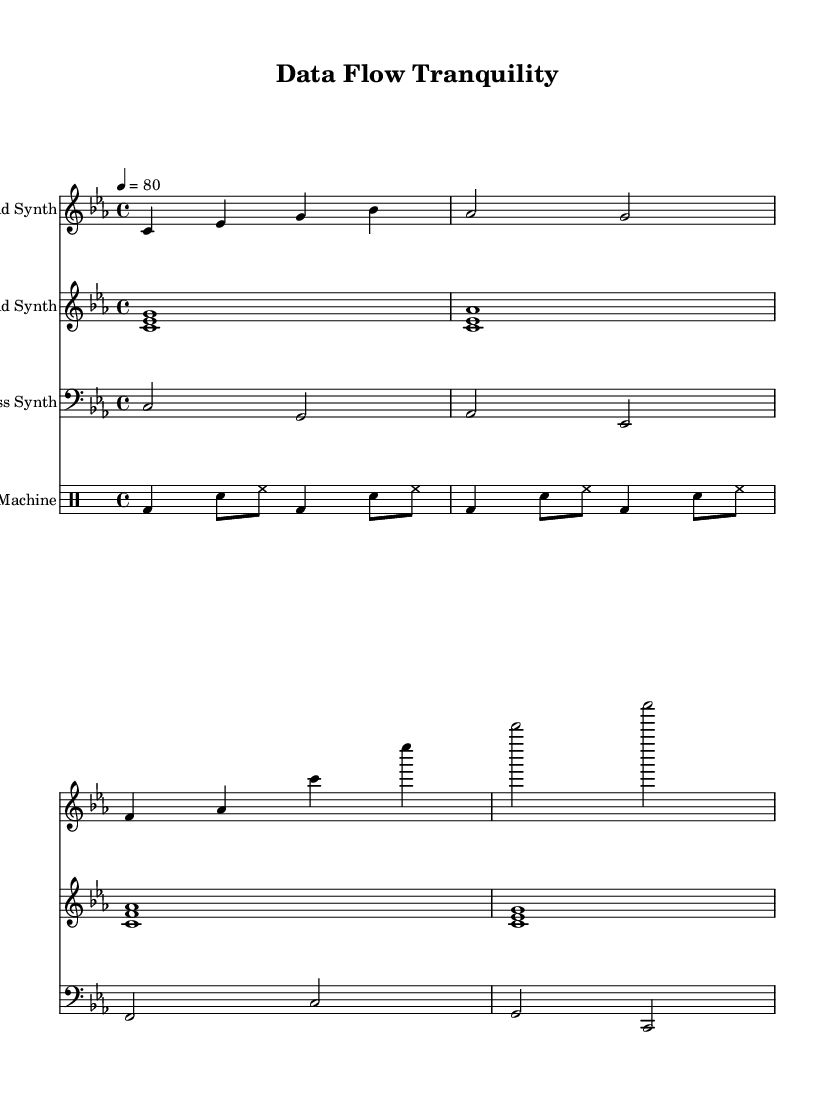What is the key signature of this music? The key signature is C minor, which is indicated by the presence of three flats (B♭, E♭, and A♭) in the key signature area.
Answer: C minor What is the time signature of this piece? The time signature is 4/4, which indicates four beats per measure and that each beat is a quarter note. This can be seen at the beginning of the score right after the key signature.
Answer: 4/4 What is the tempo marking for this piece? The tempo is marked as "4 = 80," indicating that the piece should be played at a speed of 80 beats per minute, which is typical for chill downtempo music.
Answer: 80 How many measures are there in the lead synth part? The lead synth part contains four measures based on the grouping of the notes and bar lines. Each measure is clearly delineated by vertical lines, and counting these gives a total of four.
Answer: 4 Which type of drum hits are used in the drum machine section? The drum machine section includes bass drum (bd), snare drum (sn), and hi-hat (hh) as indicated by their respective notations in the drum staff.
Answer: Bass drum, snare drum, hi-hat What is the range of the bass synth part? The bass synth part ranges from C2 to C'2, which corresponds to the notes played in that staff. This range indicates how low the bass synth can go and its highest note, giving a full depth to the sound.
Answer: C2 to C'2 What function does the pad synth serve in this composition? The pad synth serves to create an ambient background layer by playing sustained chords that enhance the overall atmosphere of the track, characteristic of chill downtempo electronic music.
Answer: Ambient background layer 